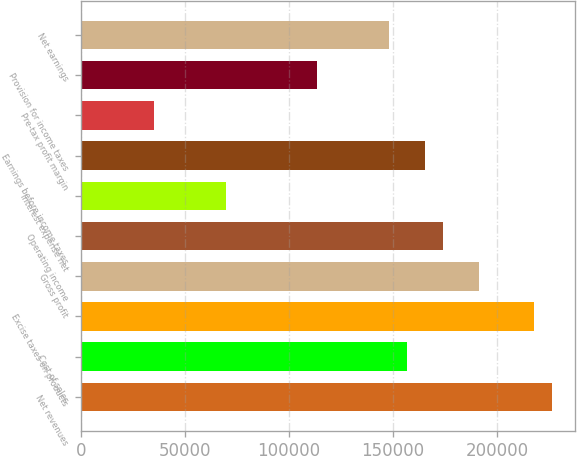Convert chart to OTSL. <chart><loc_0><loc_0><loc_500><loc_500><bar_chart><fcel>Net revenues<fcel>Cost of sales<fcel>Excise taxes on products<fcel>Gross profit<fcel>Operating income<fcel>Interest expense net<fcel>Earnings before income taxes<fcel>Pre-tax profit margin<fcel>Provision for income taxes<fcel>Net earnings<nl><fcel>226455<fcel>156777<fcel>217745<fcel>191616<fcel>174197<fcel>69680.7<fcel>165487<fcel>34842<fcel>113229<fcel>148068<nl></chart> 